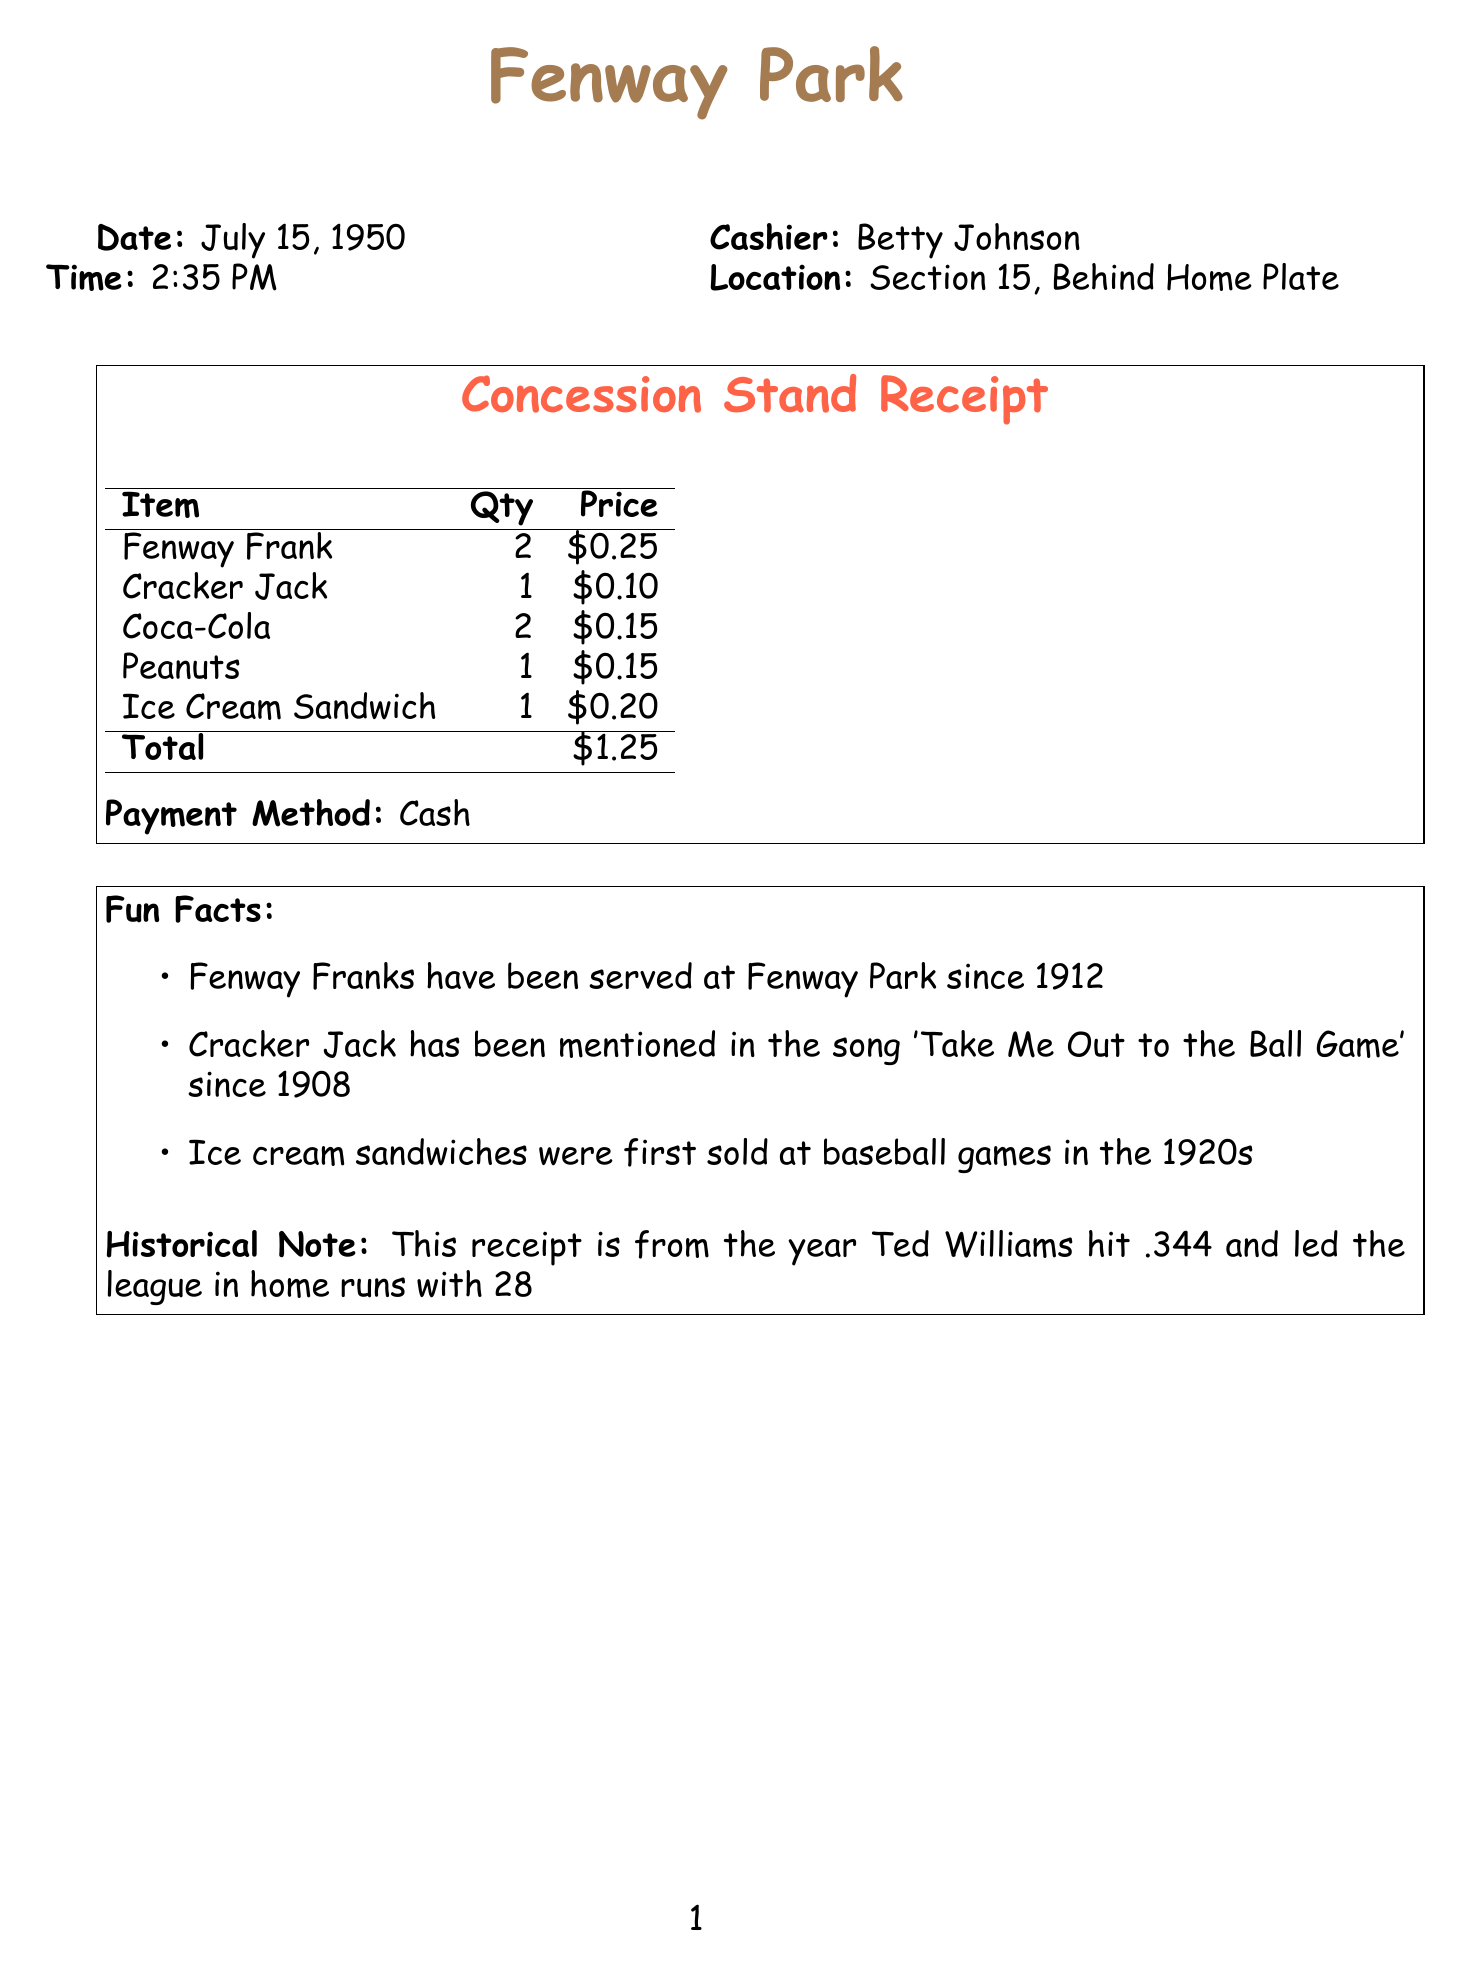What is the name of the stadium? The name of the stadium is listed at the top of the document.
Answer: Fenway Park What is the date of the receipt? The date is prominently displayed in the document.
Answer: July 15, 1950 Who was the cashier? The cashier's name is noted in the document.
Answer: Betty Johnson What is the total amount spent? The total amount is shown at the bottom of the receipt.
Answer: $1.25 How many Fenway Franks were purchased? The quantity of Fenway Franks is indicated next to the item in the receipt.
Answer: 2 What payment method was used? The payment method is specified in the receipt.
Answer: Cash Which item has been served at Fenway Park since 1912? The fun fact section mentions this historical detail.
Answer: Fenway Franks In which section is the concession stand located? The location of the concession stand is given in the document.
Answer: Section 15, Behind Home Plate What year did Ted Williams hit .344? The historical note states this important year.
Answer: 1950 